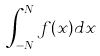Convert formula to latex. <formula><loc_0><loc_0><loc_500><loc_500>\int _ { - N } ^ { N } f ( x ) d x</formula> 